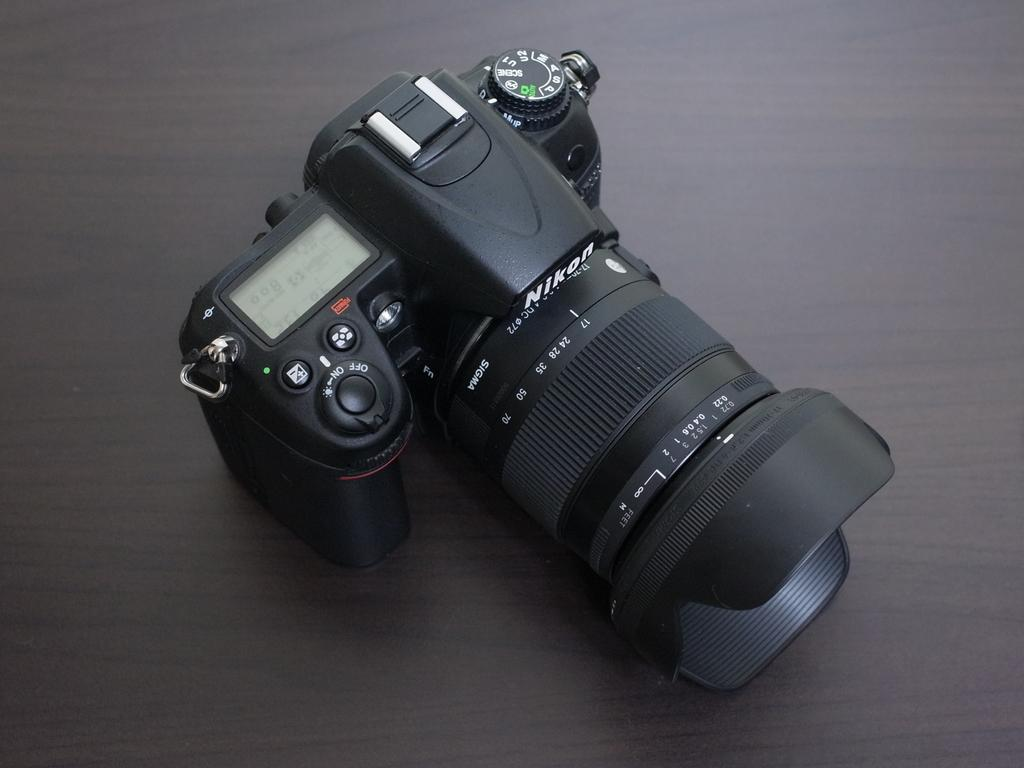<image>
Render a clear and concise summary of the photo. Black camera with the word NIKON on the top. 